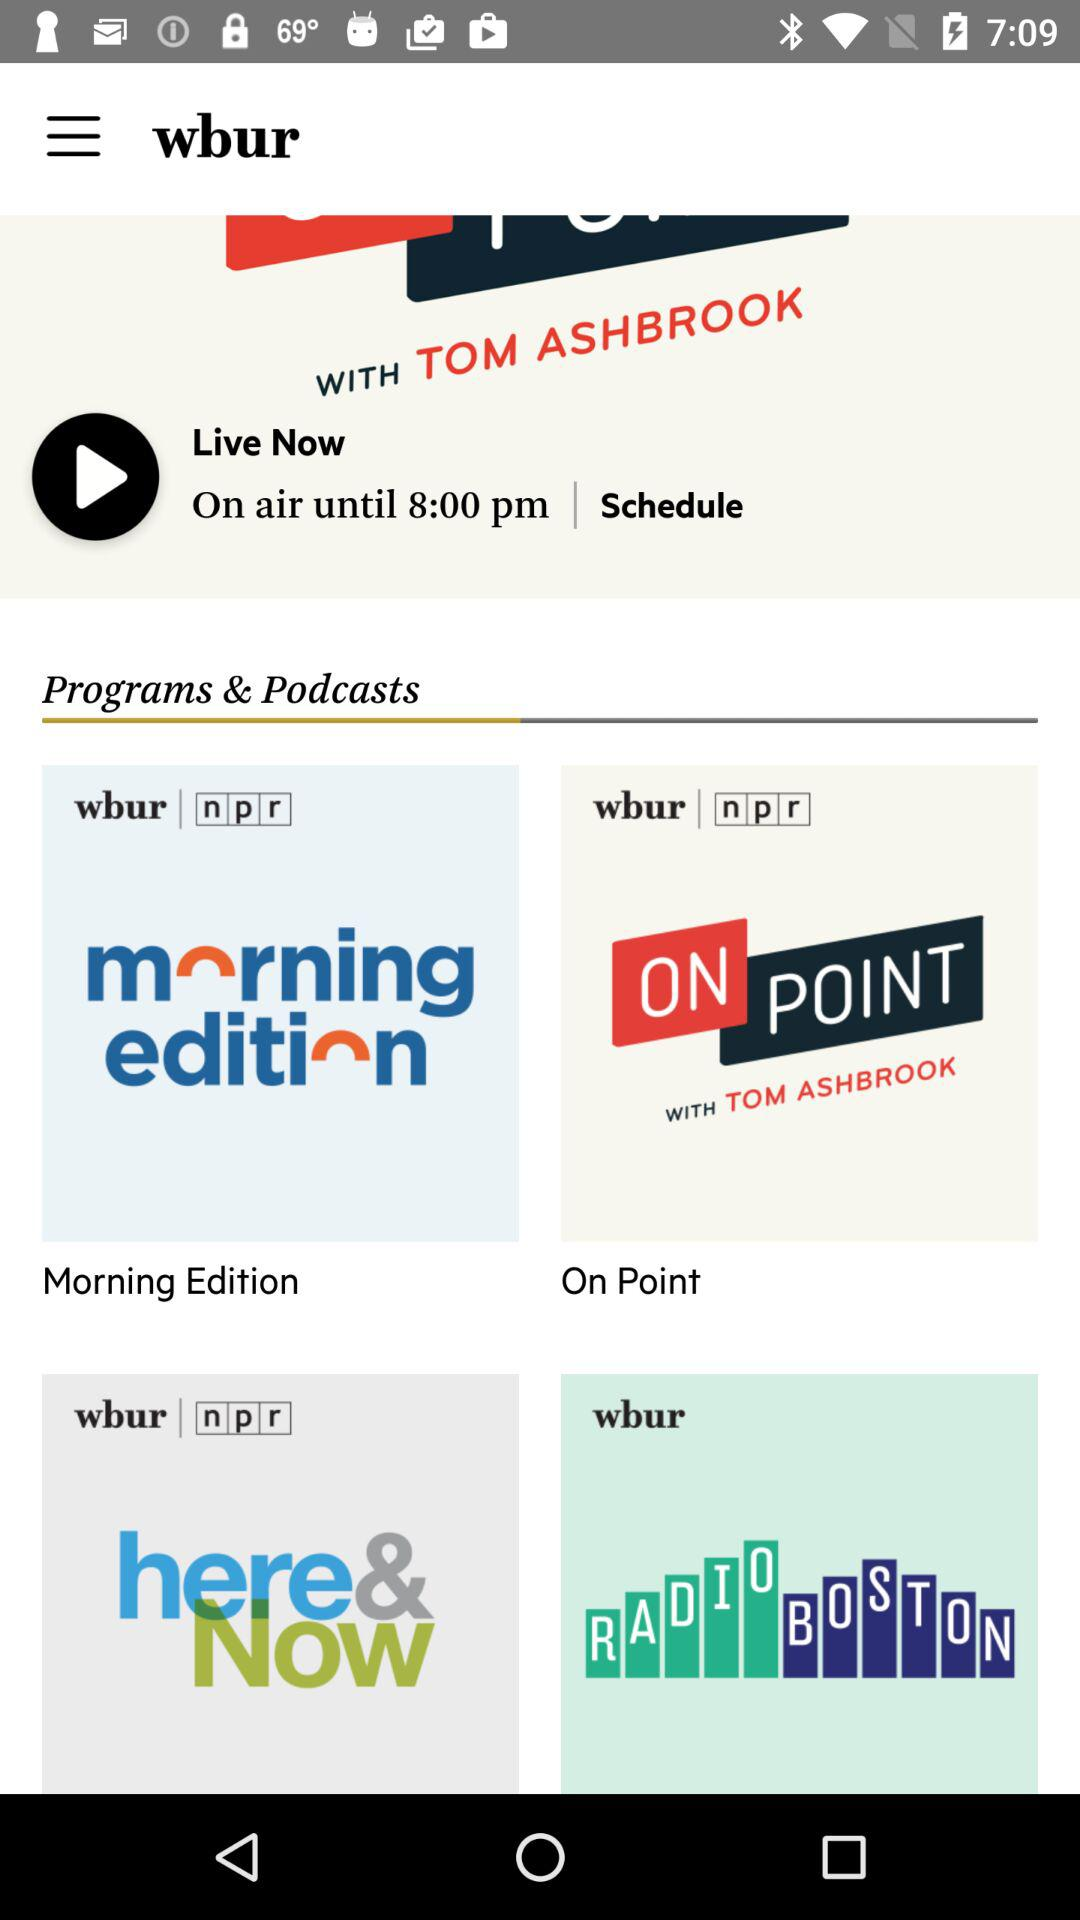Until what time is the live stream scheduled? The live stream is scheduled until 8 p.m. 